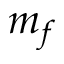<formula> <loc_0><loc_0><loc_500><loc_500>m _ { f }</formula> 